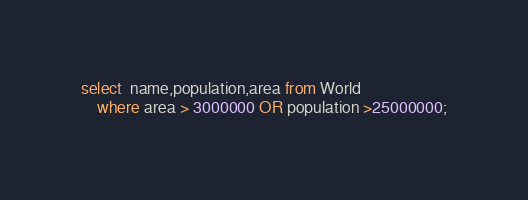<code> <loc_0><loc_0><loc_500><loc_500><_SQL_>select  name,population,area from World
    where area > 3000000 OR population >25000000;</code> 